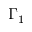Convert formula to latex. <formula><loc_0><loc_0><loc_500><loc_500>\Gamma _ { 1 }</formula> 